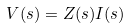<formula> <loc_0><loc_0><loc_500><loc_500>V ( s ) = Z ( s ) I ( s )</formula> 